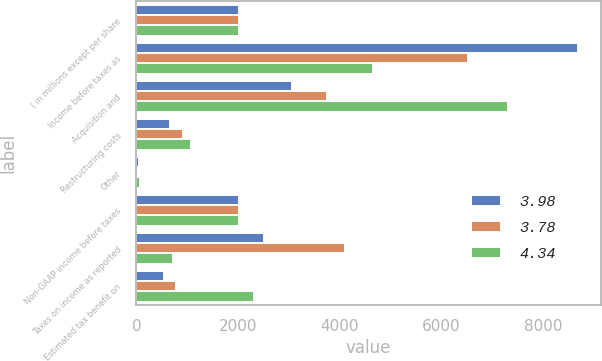<chart> <loc_0><loc_0><loc_500><loc_500><stacked_bar_chart><ecel><fcel>( in millions except per share<fcel>Income before taxes as<fcel>Acquisition and<fcel>Restructuring costs<fcel>Other<fcel>Non-GAAP income before taxes<fcel>Taxes on income as reported<fcel>Estimated tax benefit on<nl><fcel>3.98<fcel>2018<fcel>8701<fcel>3066<fcel>658<fcel>57<fcel>2017<fcel>2508<fcel>535<nl><fcel>3.78<fcel>2017<fcel>6521<fcel>3760<fcel>927<fcel>16<fcel>2017<fcel>4103<fcel>785<nl><fcel>4.34<fcel>2016<fcel>4659<fcel>7312<fcel>1069<fcel>67<fcel>2017<fcel>718<fcel>2321<nl></chart> 